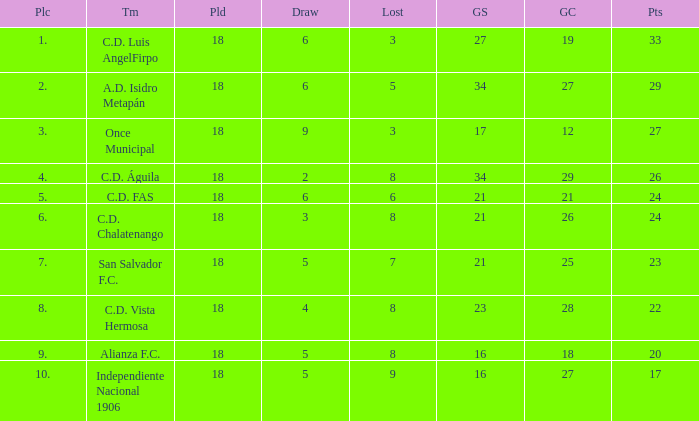What's the place that Once Municipal has a lost greater than 3? None. 